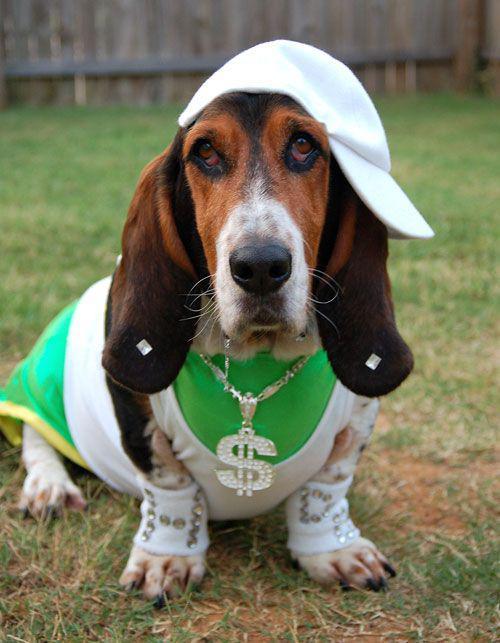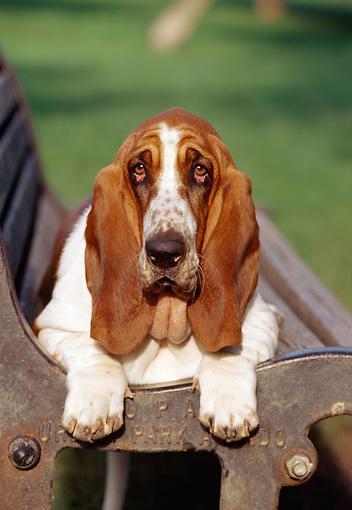The first image is the image on the left, the second image is the image on the right. Analyze the images presented: Is the assertion "One of the images shows a dog on a bench." valid? Answer yes or no. Yes. 